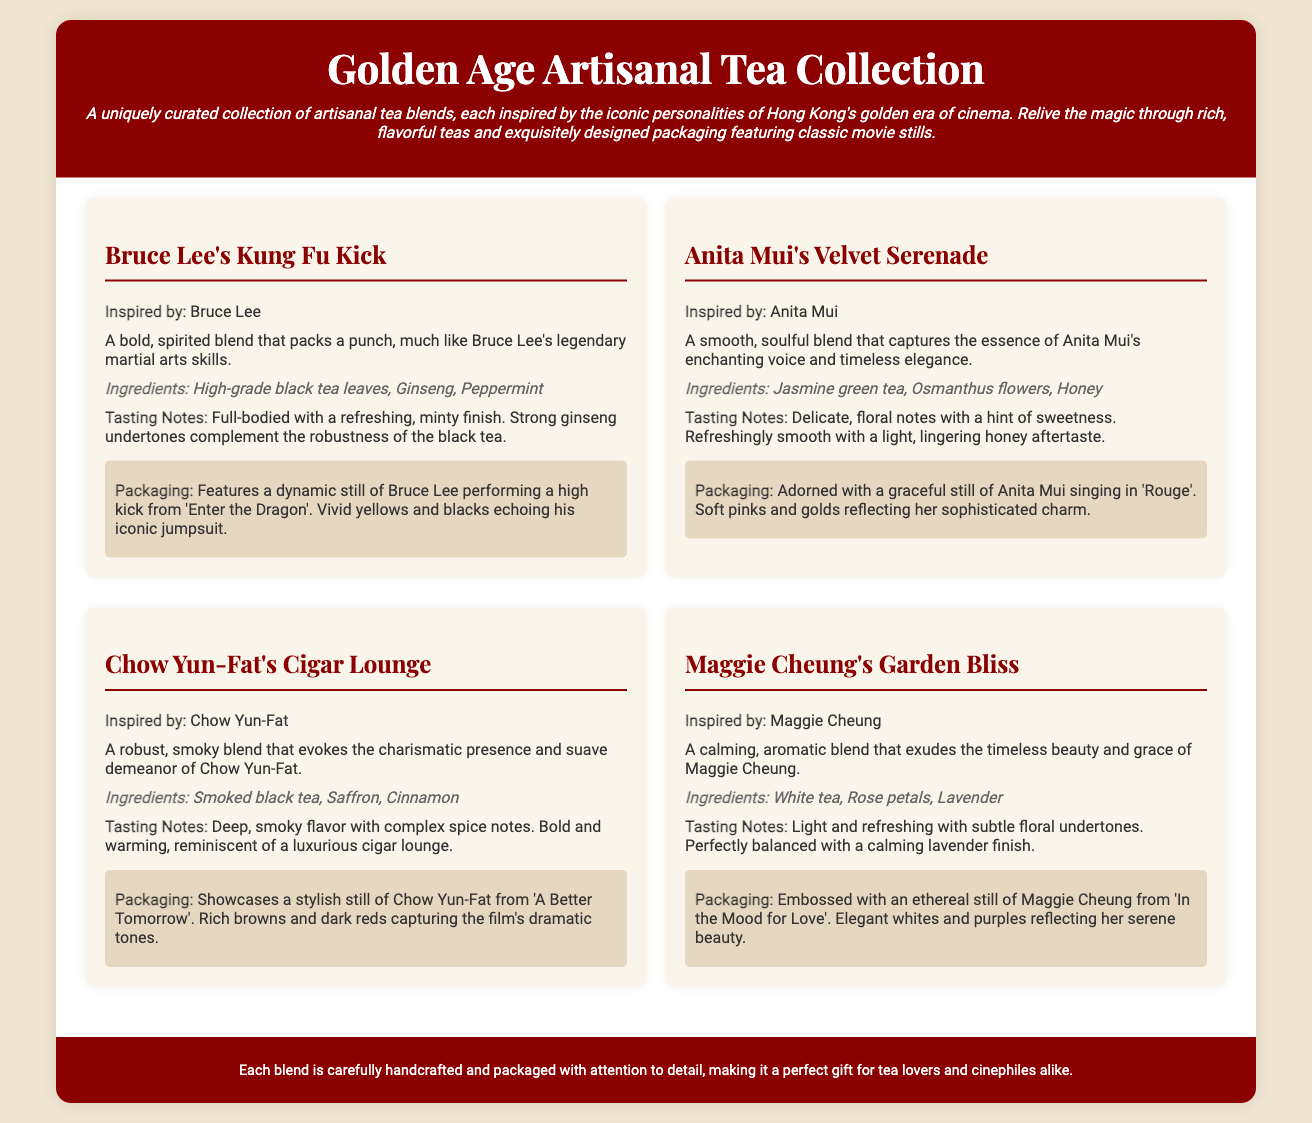What is the name of the tea inspired by Bruce Lee? The tea inspired by Bruce Lee is named "Bruce Lee's Kung Fu Kick".
Answer: Bruce Lee's Kung Fu Kick Which ingredient is used in Anita Mui's tea blend? The ingredients listed for Anita Mui's tea blend include Jasmine green tea, Osmanthus flowers, and Honey.
Answer: Jasmine green tea What flavor profile does Chow Yun-Fat's tea offer? The tea blend inspired by Chow Yun-Fat offers a deep, smoky flavor with complex spice notes.
Answer: Deep, smoky flavor How many teas are featured in this collection? The document lists a total of four unique artisanal tea blends.
Answer: Four What color scheme reflects Maggie Cheung's tea packaging? The packaging for Maggie Cheung's tea is described to have elegant whites and purples.
Answer: Elegant whites and purples Which film is associated with Chow Yun-Fat's tea packaging? Chow Yun-Fat's tea packaging features a still from the film "A Better Tomorrow".
Answer: A Better Tomorrow What type of tea is used in Maggie Cheung's Garden Bliss? The tea blend for Maggie Cheung's Garden Bliss is made with White tea.
Answer: White tea What is the overall theme of the tea collection? The theme of the tea collection is inspired by iconic personalities of Hong Kong's golden era of cinema.
Answer: Iconic personalities of Hong Kong's golden era of cinema 